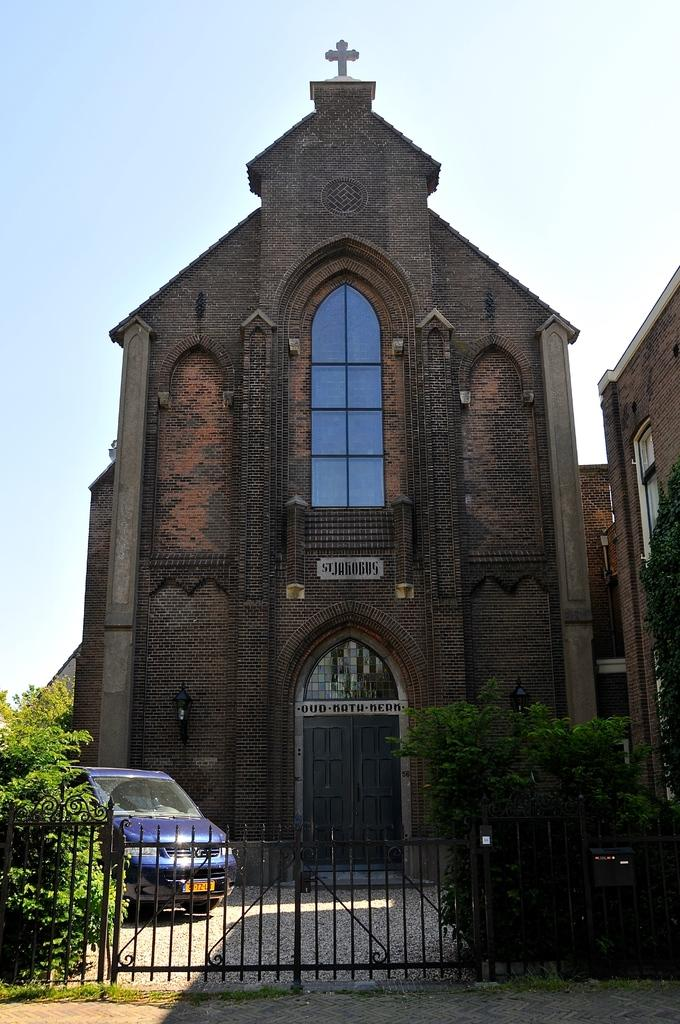What type of structure can be seen in the image? There is a fencing in the image. What other elements are present in the image? There are plants and grass on the ground in the image. What can be seen in the background of the image? There is a violet color vehicle on the road and a building in the background. What is visible in the sky in the image? The sky is visible in the image. Can you see any holes in the ground in the image? There are no holes visible in the ground in the image. What type of print can be seen on the plants in the image? There is no print on the plants in the image; they are just plants. 